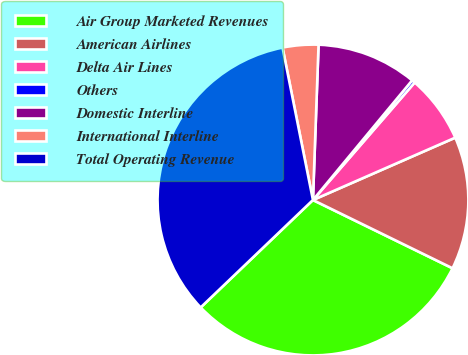<chart> <loc_0><loc_0><loc_500><loc_500><pie_chart><fcel>Air Group Marketed Revenues<fcel>American Airlines<fcel>Delta Air Lines<fcel>Others<fcel>Domestic Interline<fcel>International Interline<fcel>Total Operating Revenue<nl><fcel>30.61%<fcel>13.81%<fcel>7.07%<fcel>0.34%<fcel>10.44%<fcel>3.71%<fcel>34.01%<nl></chart> 